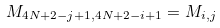Convert formula to latex. <formula><loc_0><loc_0><loc_500><loc_500>M _ { 4 N + 2 - j + 1 , 4 N + 2 - i + 1 } = M _ { i , j }</formula> 